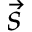Convert formula to latex. <formula><loc_0><loc_0><loc_500><loc_500>\vec { s }</formula> 